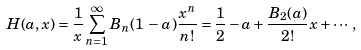Convert formula to latex. <formula><loc_0><loc_0><loc_500><loc_500>H ( a , x ) = \frac { 1 } { x } \sum _ { n = 1 } ^ { \infty } B _ { n } ( 1 \, - \, a ) \frac { x ^ { n } } { n ! } = \frac { 1 } { 2 } - a + \frac { B _ { 2 } ( a ) } { 2 ! } x + \cdots ,</formula> 